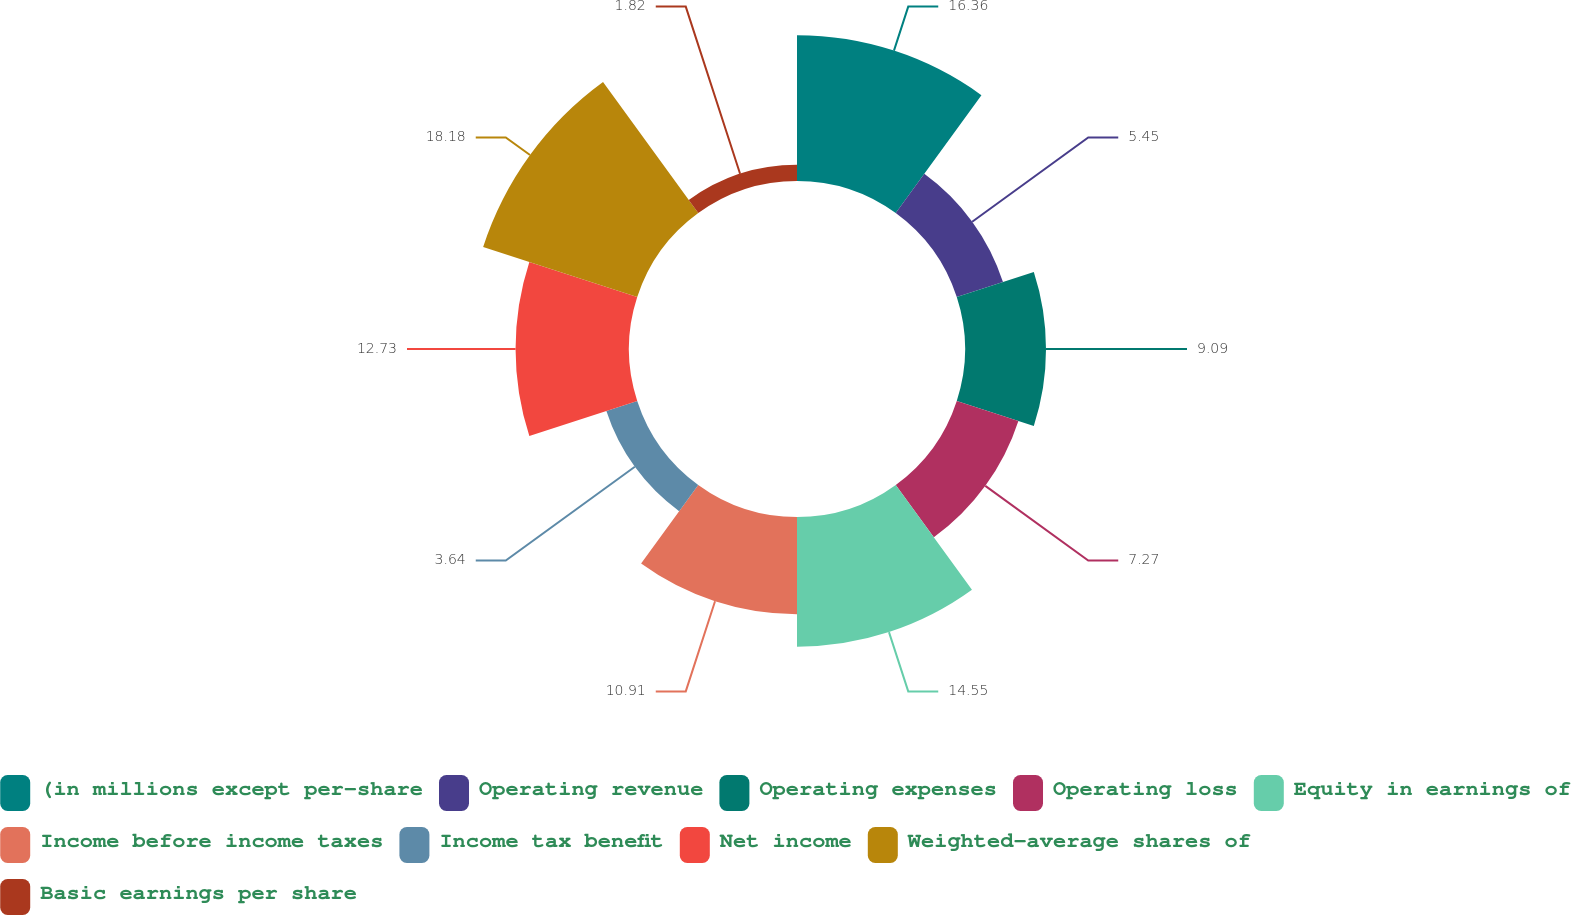Convert chart to OTSL. <chart><loc_0><loc_0><loc_500><loc_500><pie_chart><fcel>(in millions except per-share<fcel>Operating revenue<fcel>Operating expenses<fcel>Operating loss<fcel>Equity in earnings of<fcel>Income before income taxes<fcel>Income tax benefit<fcel>Net income<fcel>Weighted-average shares of<fcel>Basic earnings per share<nl><fcel>16.36%<fcel>5.45%<fcel>9.09%<fcel>7.27%<fcel>14.55%<fcel>10.91%<fcel>3.64%<fcel>12.73%<fcel>18.18%<fcel>1.82%<nl></chart> 